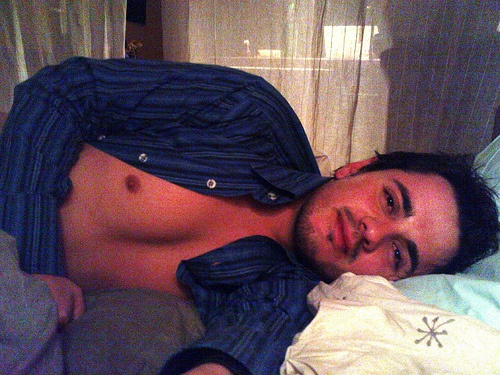Describe the objects in this image and their specific colors. I can see people in purple, black, navy, brown, and maroon tones and bed in purple, ivory, khaki, lightblue, and darkgray tones in this image. 